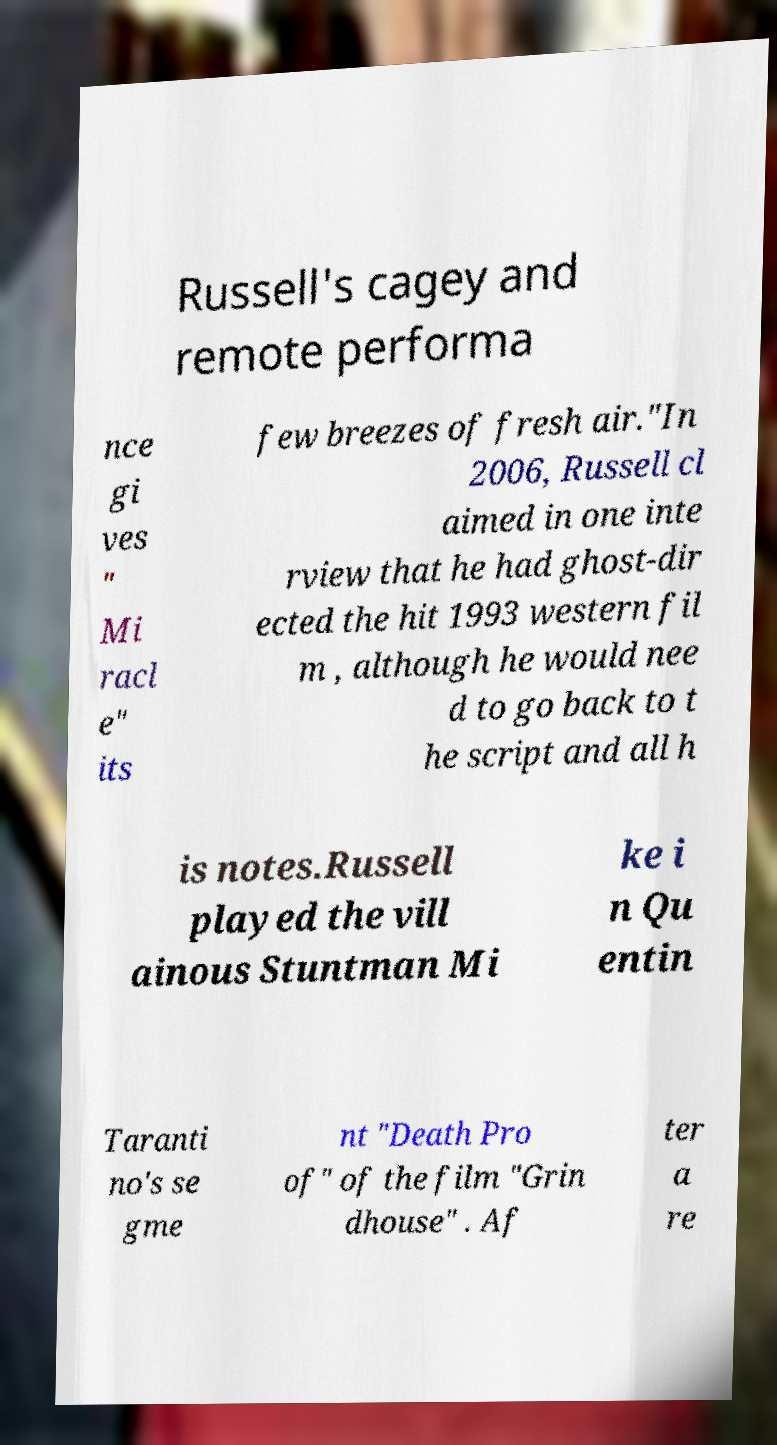Could you extract and type out the text from this image? Russell's cagey and remote performa nce gi ves " Mi racl e" its few breezes of fresh air."In 2006, Russell cl aimed in one inte rview that he had ghost-dir ected the hit 1993 western fil m , although he would nee d to go back to t he script and all h is notes.Russell played the vill ainous Stuntman Mi ke i n Qu entin Taranti no's se gme nt "Death Pro of" of the film "Grin dhouse" . Af ter a re 